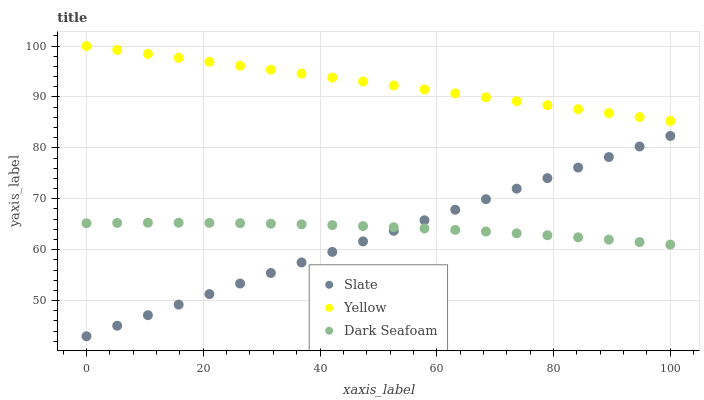Does Slate have the minimum area under the curve?
Answer yes or no. Yes. Does Yellow have the maximum area under the curve?
Answer yes or no. Yes. Does Dark Seafoam have the minimum area under the curve?
Answer yes or no. No. Does Dark Seafoam have the maximum area under the curve?
Answer yes or no. No. Is Slate the smoothest?
Answer yes or no. Yes. Is Dark Seafoam the roughest?
Answer yes or no. Yes. Is Yellow the smoothest?
Answer yes or no. No. Is Yellow the roughest?
Answer yes or no. No. Does Slate have the lowest value?
Answer yes or no. Yes. Does Dark Seafoam have the lowest value?
Answer yes or no. No. Does Yellow have the highest value?
Answer yes or no. Yes. Does Dark Seafoam have the highest value?
Answer yes or no. No. Is Dark Seafoam less than Yellow?
Answer yes or no. Yes. Is Yellow greater than Dark Seafoam?
Answer yes or no. Yes. Does Slate intersect Dark Seafoam?
Answer yes or no. Yes. Is Slate less than Dark Seafoam?
Answer yes or no. No. Is Slate greater than Dark Seafoam?
Answer yes or no. No. Does Dark Seafoam intersect Yellow?
Answer yes or no. No. 